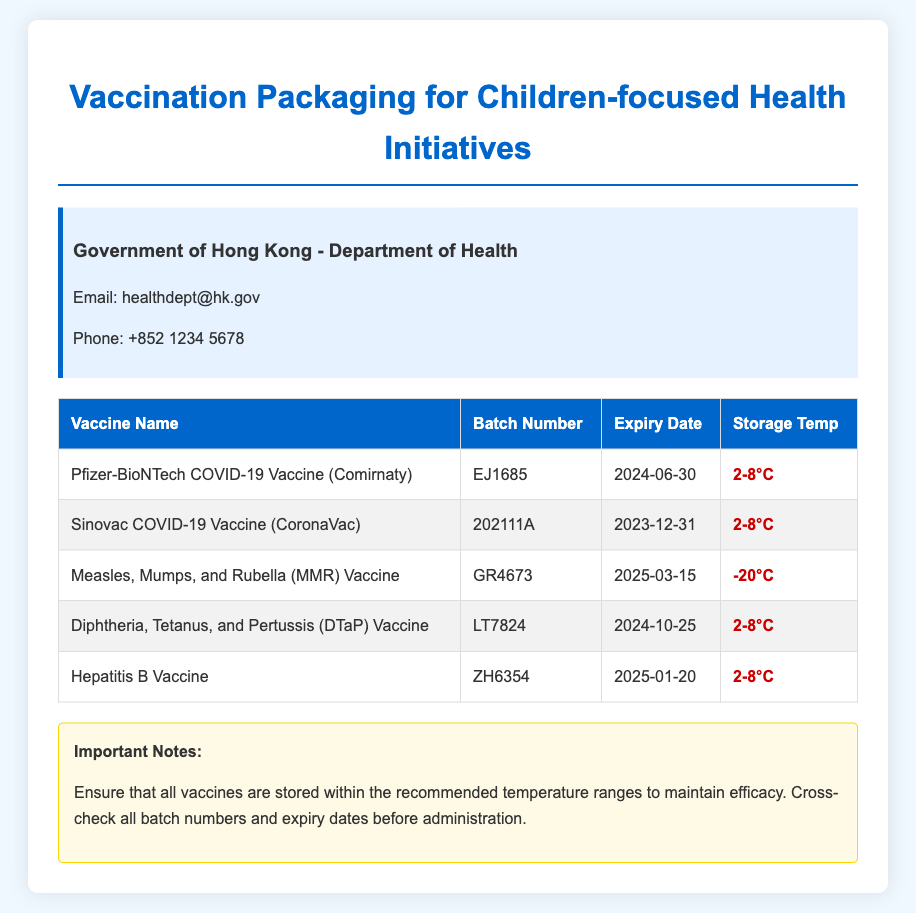What is the batch number for the Pfizer-BioNTech COVID-19 Vaccine? The batch number is listed in the table under the respective vaccine name.
Answer: EJ1685 What is the expiry date of the Sinovac COVID-19 Vaccine? The expiry date is provided for each vaccine in the table.
Answer: 2023-12-31 What temperature should the Measles, Mumps, and Rubella Vaccine be stored at? The storage temperature is indicated beside each vaccine in the table.
Answer: -20°C Which vaccine has an expiry date of 2025-01-20? This requires looking for the date in the table and matching it with the vaccine name.
Answer: Hepatitis B Vaccine How many vaccines listed expire after 2024? This involves counting the vaccines in the table that have expiry dates subsequent to 2024.
Answer: 3 What is the storage temperature range for Diphtheria, Tetanus, and Pertussis Vaccine? Refers to the information provided about the temperature beside the vaccine name in the table.
Answer: 2-8°C What important note is provided regarding the storage of vaccines? The notes section contains critical information about vaccine handling.
Answer: Ensure that all vaccines are stored within the recommended temperature ranges to maintain efficacy Is the Government of Hong Kong's Department of Health contact email included in the document? The document features a section with official contact information.
Answer: Yes 